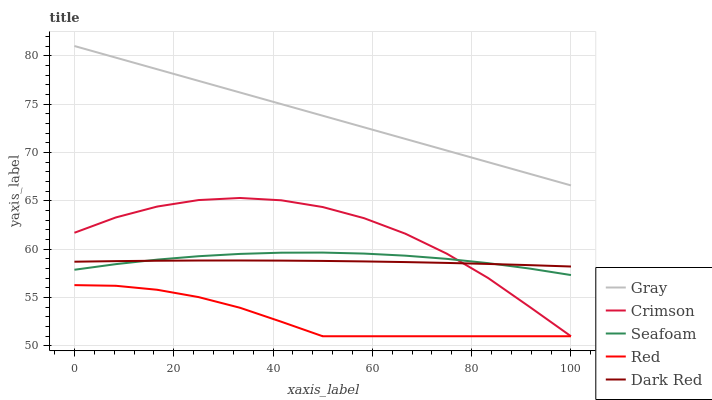Does Red have the minimum area under the curve?
Answer yes or no. Yes. Does Gray have the maximum area under the curve?
Answer yes or no. Yes. Does Seafoam have the minimum area under the curve?
Answer yes or no. No. Does Seafoam have the maximum area under the curve?
Answer yes or no. No. Is Gray the smoothest?
Answer yes or no. Yes. Is Crimson the roughest?
Answer yes or no. Yes. Is Seafoam the smoothest?
Answer yes or no. No. Is Seafoam the roughest?
Answer yes or no. No. Does Crimson have the lowest value?
Answer yes or no. Yes. Does Seafoam have the lowest value?
Answer yes or no. No. Does Gray have the highest value?
Answer yes or no. Yes. Does Seafoam have the highest value?
Answer yes or no. No. Is Crimson less than Gray?
Answer yes or no. Yes. Is Seafoam greater than Red?
Answer yes or no. Yes. Does Dark Red intersect Seafoam?
Answer yes or no. Yes. Is Dark Red less than Seafoam?
Answer yes or no. No. Is Dark Red greater than Seafoam?
Answer yes or no. No. Does Crimson intersect Gray?
Answer yes or no. No. 